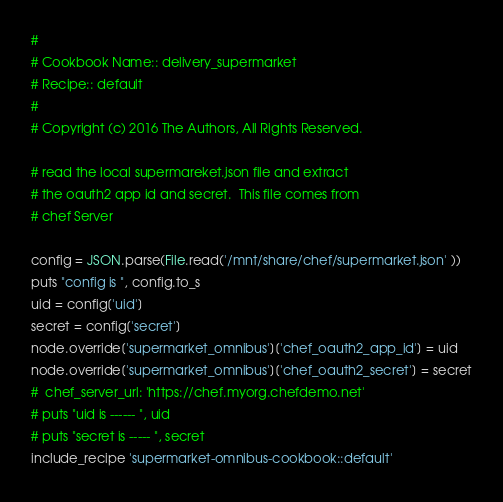<code> <loc_0><loc_0><loc_500><loc_500><_Ruby_>#
# Cookbook Name:: delivery_supermarket
# Recipe:: default
#
# Copyright (c) 2016 The Authors, All Rights Reserved.

# read the local supermareket.json file and extract
# the oauth2 app id and secret.  This file comes from
# chef Server

config = JSON.parse(File.read('/mnt/share/chef/supermarket.json' ))
puts "config is ", config.to_s
uid = config['uid']
secret = config['secret']
node.override['supermarket_omnibus']['chef_oauth2_app_id'] = uid
node.override['supermarket_omnibus']['chef_oauth2_secret'] = secret
#  chef_server_url: 'https://chef.myorg.chefdemo.net'
# puts "uid is ------ ", uid
# puts "secret is ----- ", secret
include_recipe 'supermarket-omnibus-cookbook::default'
</code> 